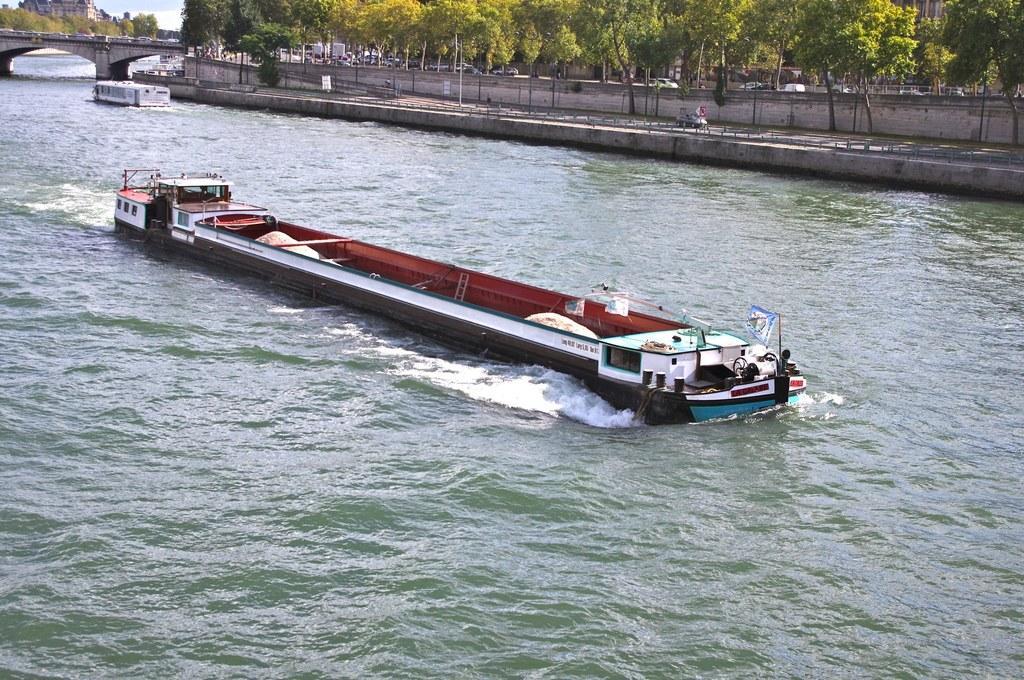Could you give a brief overview of what you see in this image? In this picture I can see a board in the middle and there is water, on the left side there is a bridge. In the background there are trees and vehicles. 